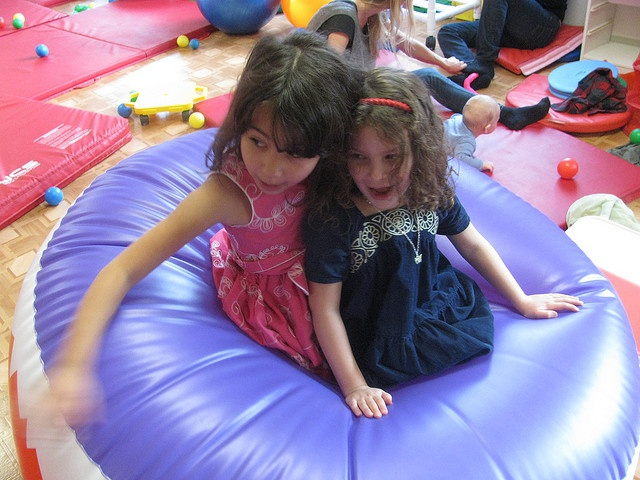Describe the objects in this image and their specific colors. I can see people in salmon, black, brown, and maroon tones, people in salmon, black, gray, navy, and maroon tones, people in salmon, black, navy, and blue tones, people in salmon, gray, brown, darkgray, and black tones, and sports ball in salmon, violet, lightpink, and red tones in this image. 